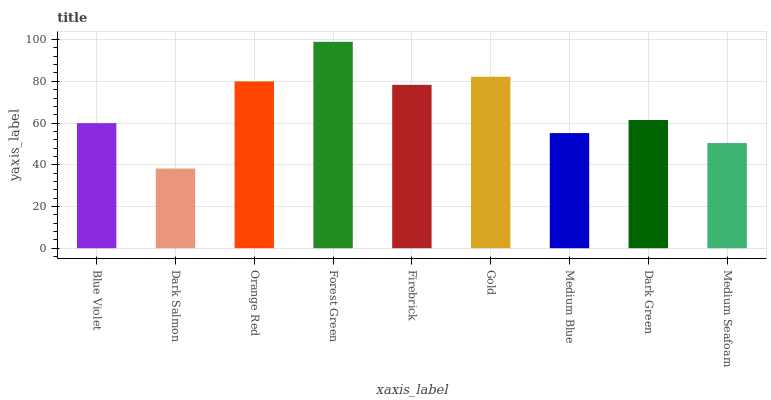Is Dark Salmon the minimum?
Answer yes or no. Yes. Is Forest Green the maximum?
Answer yes or no. Yes. Is Orange Red the minimum?
Answer yes or no. No. Is Orange Red the maximum?
Answer yes or no. No. Is Orange Red greater than Dark Salmon?
Answer yes or no. Yes. Is Dark Salmon less than Orange Red?
Answer yes or no. Yes. Is Dark Salmon greater than Orange Red?
Answer yes or no. No. Is Orange Red less than Dark Salmon?
Answer yes or no. No. Is Dark Green the high median?
Answer yes or no. Yes. Is Dark Green the low median?
Answer yes or no. Yes. Is Medium Seafoam the high median?
Answer yes or no. No. Is Blue Violet the low median?
Answer yes or no. No. 